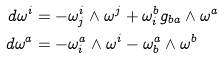Convert formula to latex. <formula><loc_0><loc_0><loc_500><loc_500>d \omega ^ { i } & = - \omega _ { j } ^ { i } \wedge \omega ^ { j } + \omega ^ { b } _ { i } g _ { b a } \wedge \omega ^ { a } \\ d \omega ^ { a } & = - \omega ^ { a } _ { i } \wedge \omega ^ { i } - \omega ^ { a } _ { b } \wedge \omega ^ { b }</formula> 